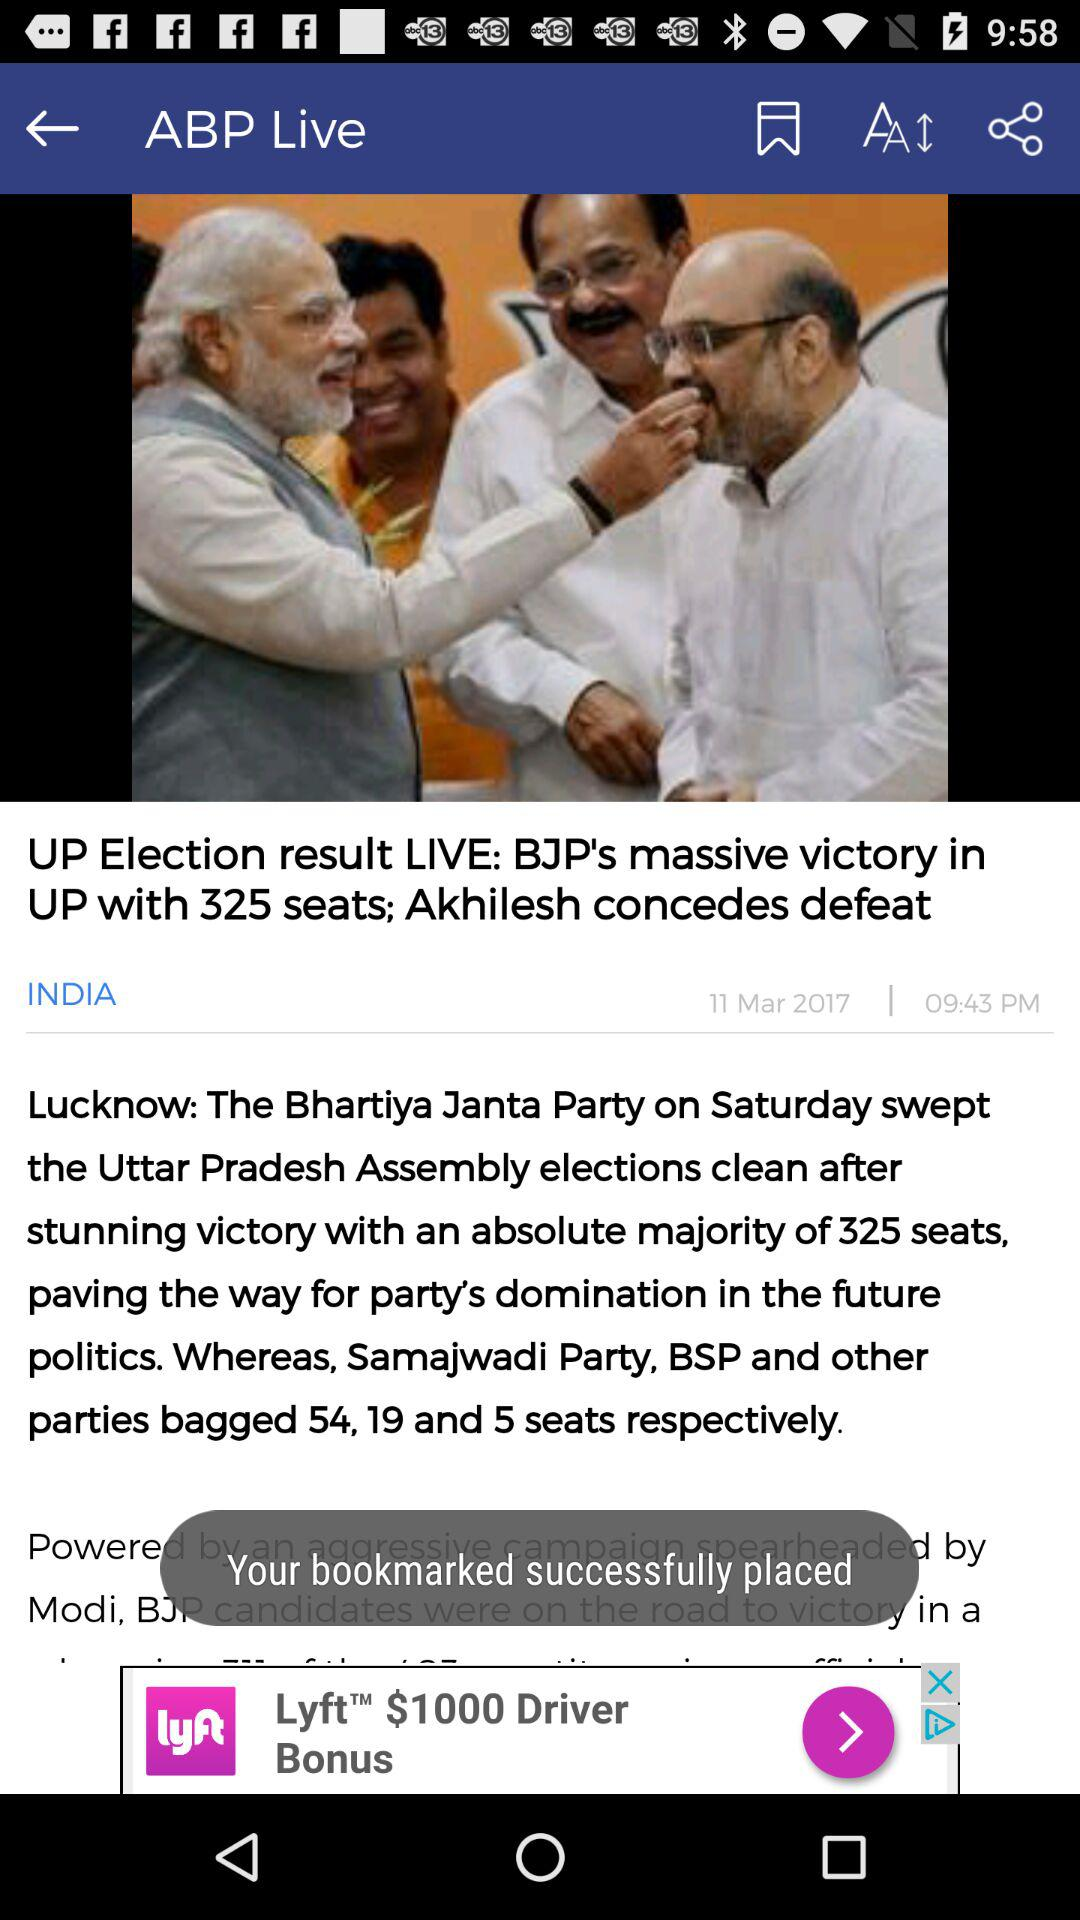How many more seats did the BJP win than the Samajwadi Party?
Answer the question using a single word or phrase. 271 